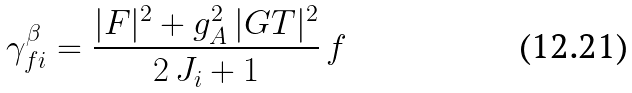<formula> <loc_0><loc_0><loc_500><loc_500>\gamma ^ { \beta } _ { f i } = \frac { | F | ^ { 2 } + g _ { A } ^ { 2 } \, | G T | ^ { 2 } } { 2 \, J _ { i } + 1 } \, f</formula> 